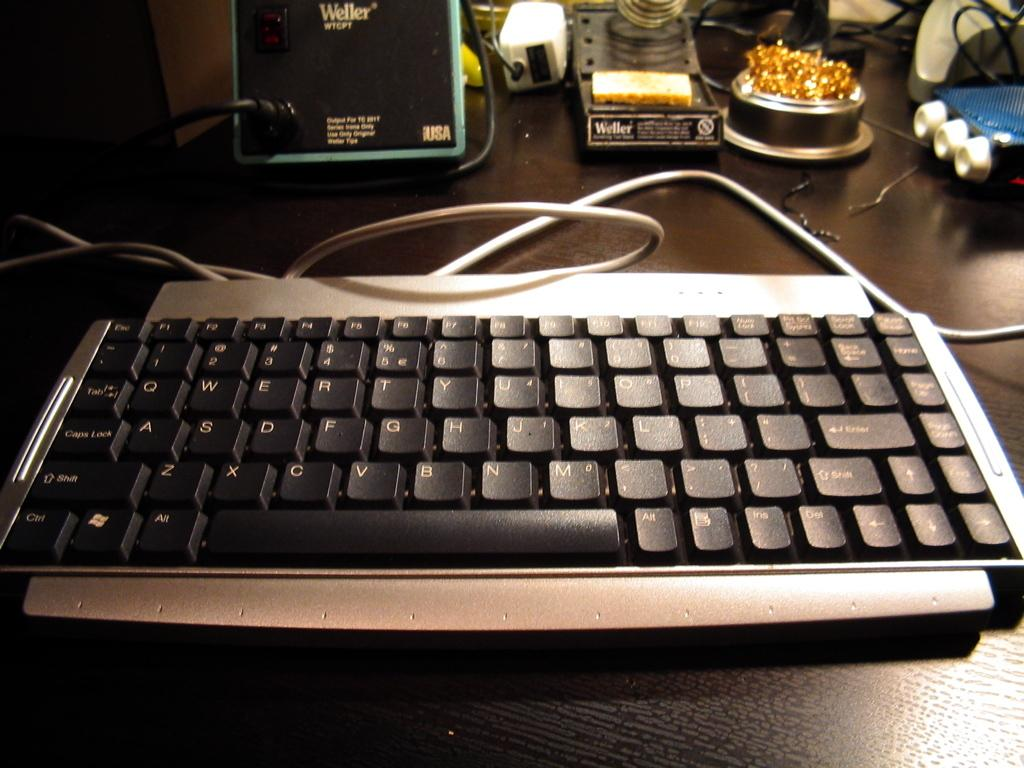<image>
Give a short and clear explanation of the subsequent image. a keyboard in front of something that has the word Weller on it 